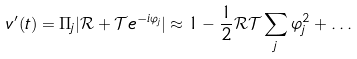Convert formula to latex. <formula><loc_0><loc_0><loc_500><loc_500>v ^ { \prime } ( t ) = \Pi _ { j } | \mathcal { R } + \mathcal { T } e ^ { - i \varphi _ { j } } | \approx 1 - \frac { 1 } { 2 } \mathcal { R T } \sum _ { j } \varphi _ { j } ^ { 2 } + \dots</formula> 